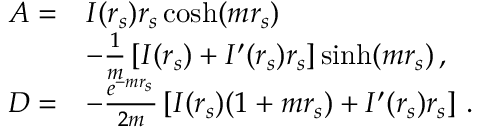<formula> <loc_0><loc_0><loc_500><loc_500>\begin{array} { r l } { A = } & { I ( r _ { s } ) r _ { s } \cosh ( m r _ { s } ) } \\ & { - \frac { 1 } { m } \left [ I ( r _ { s } ) + I ^ { \prime } ( r _ { s } ) r _ { s } \right ] \sinh ( m r _ { s } ) \, , } \\ { D = } & { - \frac { e ^ { - m r _ { s } } } { 2 m } \left [ I ( r _ { s } ) ( 1 + m r _ { s } ) + I ^ { \prime } ( r _ { s } ) r _ { s } \right ] \, . } \end{array}</formula> 